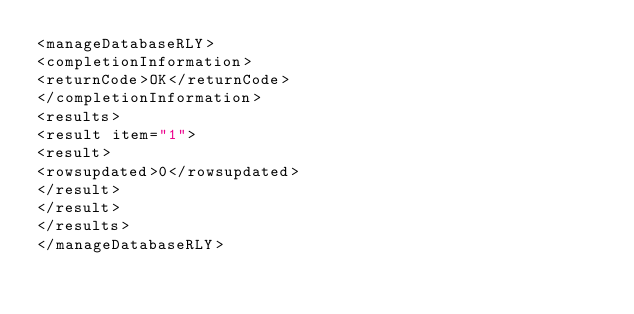Convert code to text. <code><loc_0><loc_0><loc_500><loc_500><_XML_><manageDatabaseRLY>
<completionInformation>
<returnCode>OK</returnCode>
</completionInformation>
<results>
<result item="1">
<result>
<rowsupdated>0</rowsupdated>
</result>
</result>
</results>
</manageDatabaseRLY>
</code> 